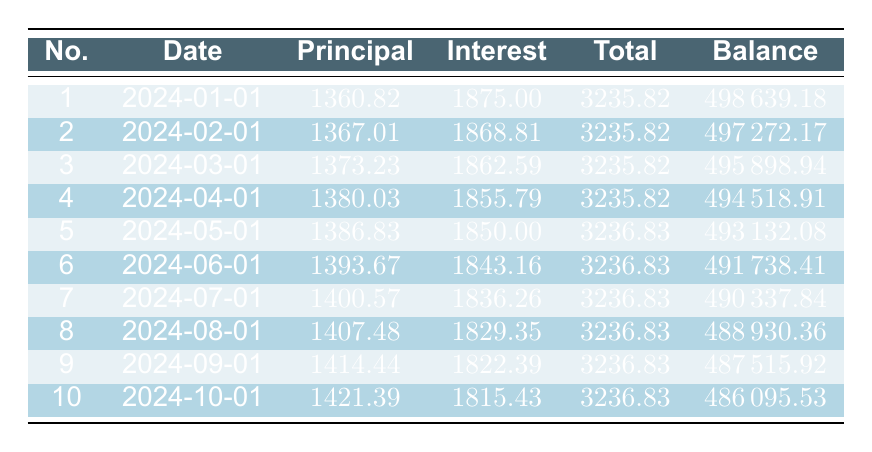What is the total payment for the first installment? Referring to the first row of the table, the total payment for the first installment is directly listed as 3235.82.
Answer: 3235.82 How much is the principal payment in the fifth installment? Looking at the fifth row, the principal payment is clearly stated as 1386.83.
Answer: 1386.83 What is the remaining balance after the third payment? The table shows the remaining balance after the third payment in the third row, which is 495898.94.
Answer: 495898.94 What is the difference between the total payments of the fifth and the sixth installment? From the fifth row, the total payment for the fifth installment is 3236.83, and for the sixth installment, it is 3236.83 as well. The difference is 3236.83 - 3236.83 = 0.
Answer: 0 Did the principal payment increase from the first to the second installment? By comparing the principal payment in the first installment (1360.82) and the second installment (1367.01), we see that 1367.01 is greater than 1360.82. Therefore, the answer is yes.
Answer: Yes What is the total principal paid after the first four payments? The principal payments for the first four installments are 1360.82, 1367.01, 1373.23, and 1380.03. Summing these values gives 1360.82 + 1367.01 + 1373.23 + 1380.03 = 5461.09.
Answer: 5461.09 How much has the interest payment decreased from the first to the tenth installment? The interest payment for the first installment is 1875.00 and for the tenth installment is 1815.43. The decrease is 1875.00 - 1815.43 = 59.57.
Answer: 59.57 Is the total payment consistent for all installments? By checking the total payments in the table, we can see that the first installment is 3235.82 and the other installments (2 to 10) are all 3236.83. Since they do not share the same value, the answer is no.
Answer: No What is the average principal payment for the first ten installments? The principal payments for the ten installments are shown in the table. Summing them gives 1360.82 + 1367.01 + 1373.23 + 1380.03 + 1386.83 + 1393.67 + 1400.57 + 1407.48 + 1414.44 + 1421.39 = 1399.13. To find the average, we divide by 10, resulting in 1399.13 / 10 = 1399.13.
Answer: 1399.13 